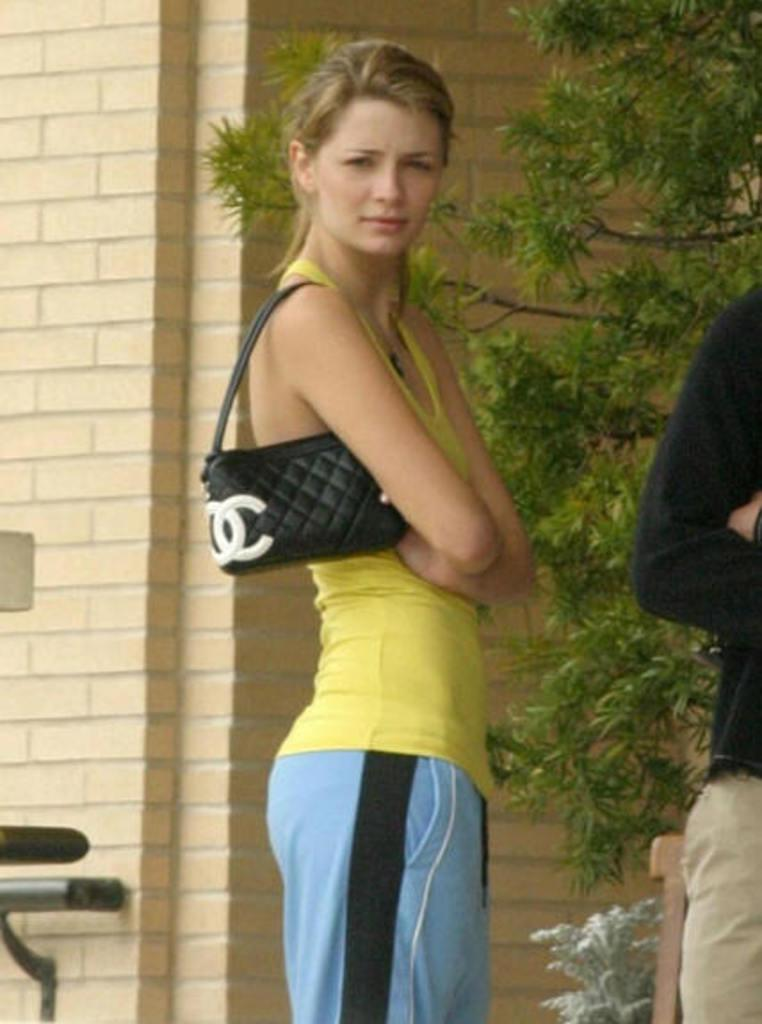What is the woman in the image doing? The woman is standing in the image and looking at something. What is the woman carrying in the image? The woman is carrying a handbag in the image. Who is beside the woman in the image? There is a person beside the woman in the image. What can be seen in the background of the image? There is a brick wall and a tree in the background of the image. What type of pickle is the woman holding in the image? There is no pickle present in the image; the woman is carrying a handbag. What is the woman using to ride the rail in the image? There is no rail or any indication of transportation in the image; the woman is standing and looking at something. 